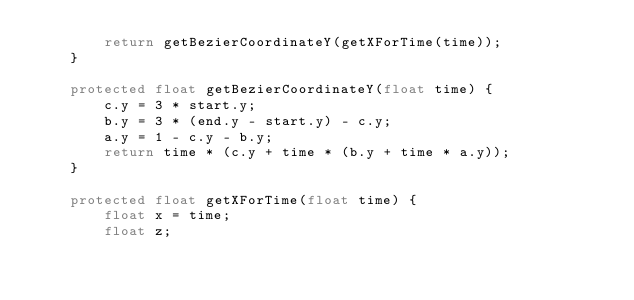Convert code to text. <code><loc_0><loc_0><loc_500><loc_500><_Java_>        return getBezierCoordinateY(getXForTime(time));
    }

    protected float getBezierCoordinateY(float time) {
        c.y = 3 * start.y;
        b.y = 3 * (end.y - start.y) - c.y;
        a.y = 1 - c.y - b.y;
        return time * (c.y + time * (b.y + time * a.y));
    }

    protected float getXForTime(float time) {
        float x = time;
        float z;</code> 